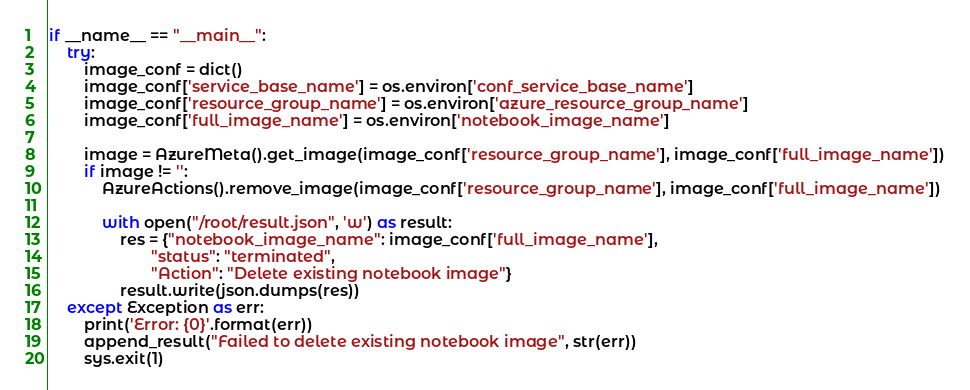Convert code to text. <code><loc_0><loc_0><loc_500><loc_500><_Python_>
if __name__ == "__main__":
    try:
        image_conf = dict()
        image_conf['service_base_name'] = os.environ['conf_service_base_name']
        image_conf['resource_group_name'] = os.environ['azure_resource_group_name']
        image_conf['full_image_name'] = os.environ['notebook_image_name']

        image = AzureMeta().get_image(image_conf['resource_group_name'], image_conf['full_image_name'])
        if image != '':
            AzureActions().remove_image(image_conf['resource_group_name'], image_conf['full_image_name'])

            with open("/root/result.json", 'w') as result:
                res = {"notebook_image_name": image_conf['full_image_name'],
                       "status": "terminated",
                       "Action": "Delete existing notebook image"}
                result.write(json.dumps(res))
    except Exception as err:
        print('Error: {0}'.format(err))
        append_result("Failed to delete existing notebook image", str(err))
        sys.exit(1)</code> 